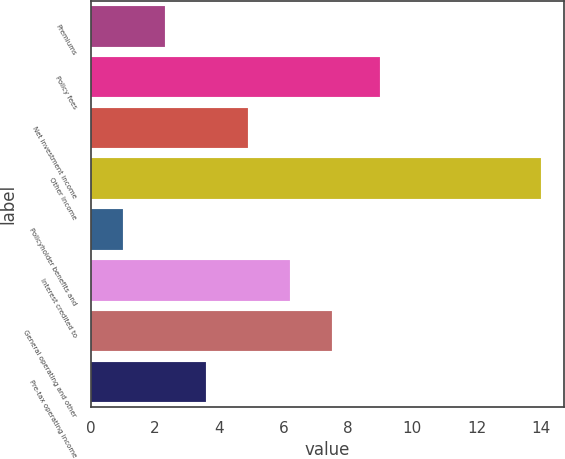Convert chart. <chart><loc_0><loc_0><loc_500><loc_500><bar_chart><fcel>Premiums<fcel>Policy fees<fcel>Net investment income<fcel>Other income<fcel>Policyholder benefits and<fcel>Interest credited to<fcel>General operating and other<fcel>Pre-tax operating income<nl><fcel>2.3<fcel>9<fcel>4.9<fcel>14<fcel>1<fcel>6.2<fcel>7.5<fcel>3.6<nl></chart> 